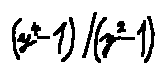Convert formula to latex. <formula><loc_0><loc_0><loc_500><loc_500>( y ^ { 4 } - 1 ) / ( y ^ { 2 } - 1 )</formula> 